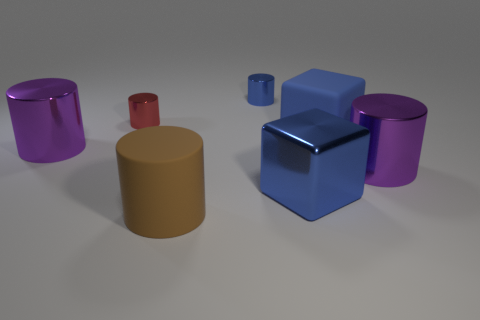Do the tiny blue cylinder and the purple cylinder to the right of the tiny red cylinder have the same material?
Offer a very short reply. Yes. There is a red cylinder that is to the left of the blue shiny cube; what size is it?
Offer a terse response. Small. Are there fewer blue cylinders than big cubes?
Offer a very short reply. Yes. Is there a large rubber object that has the same color as the big rubber cylinder?
Your answer should be very brief. No. There is a metal object that is both in front of the large blue rubber cube and left of the big blue metal block; what shape is it?
Make the answer very short. Cylinder. What is the shape of the large purple metallic thing right of the small metal object that is left of the small blue object?
Ensure brevity in your answer.  Cylinder. Do the red object and the big brown thing have the same shape?
Your response must be concise. Yes. What is the material of the tiny thing that is the same color as the rubber cube?
Make the answer very short. Metal. Is the large shiny block the same color as the matte block?
Make the answer very short. Yes. How many objects are to the right of the large rubber object to the right of the tiny cylinder that is to the right of the big brown matte object?
Offer a terse response. 1. 